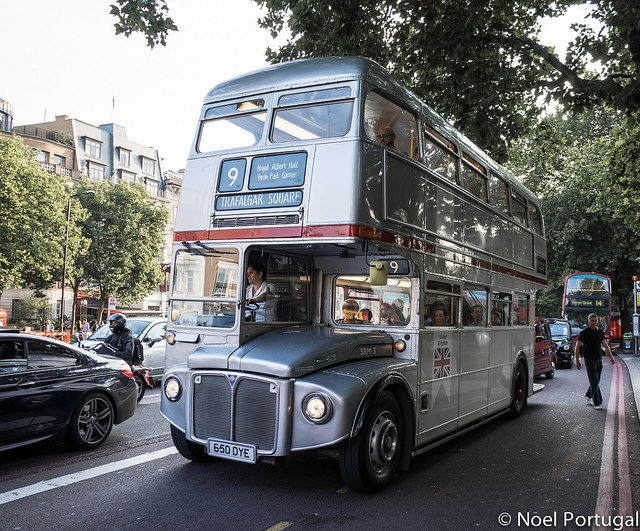Describe the objects in this image and their specific colors. I can see bus in white, black, gray, lightgray, and darkgray tones, car in white, black, gray, lightgray, and darkgray tones, bus in white, black, gray, and blue tones, car in white, lightgray, darkgray, and lightblue tones, and people in white, black, gray, and darkgray tones in this image. 